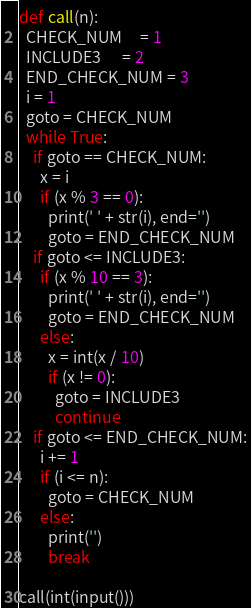<code> <loc_0><loc_0><loc_500><loc_500><_Python_>def call(n):
  CHECK_NUM     = 1
  INCLUDE3      = 2
  END_CHECK_NUM = 3
  i = 1
  goto = CHECK_NUM
  while True:
    if goto == CHECK_NUM:
      x = i
      if (x % 3 == 0):
        print(' ' + str(i), end='')
        goto = END_CHECK_NUM
    if goto <= INCLUDE3:
      if (x % 10 == 3):
        print(' ' + str(i), end='')
        goto = END_CHECK_NUM
      else:
        x = int(x / 10)
        if (x != 0):
          goto = INCLUDE3
          continue
    if goto <= END_CHECK_NUM:
      i += 1
      if (i <= n):
        goto = CHECK_NUM
      else:
        print('')
        break

call(int(input()))
</code> 